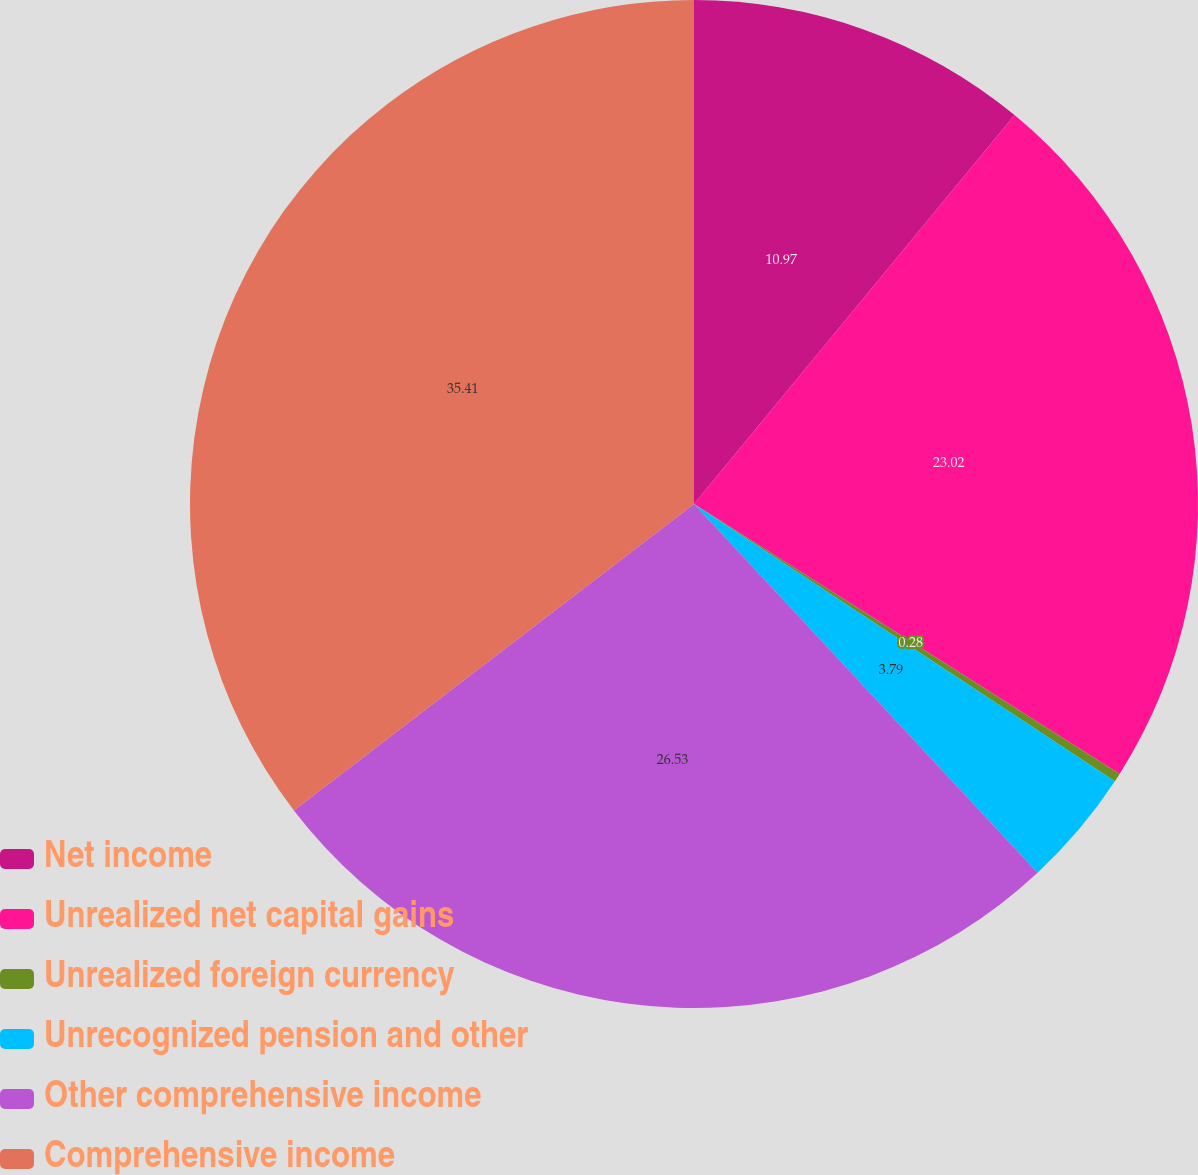Convert chart to OTSL. <chart><loc_0><loc_0><loc_500><loc_500><pie_chart><fcel>Net income<fcel>Unrealized net capital gains<fcel>Unrealized foreign currency<fcel>Unrecognized pension and other<fcel>Other comprehensive income<fcel>Comprehensive income<nl><fcel>10.97%<fcel>23.02%<fcel>0.28%<fcel>3.79%<fcel>26.53%<fcel>35.4%<nl></chart> 